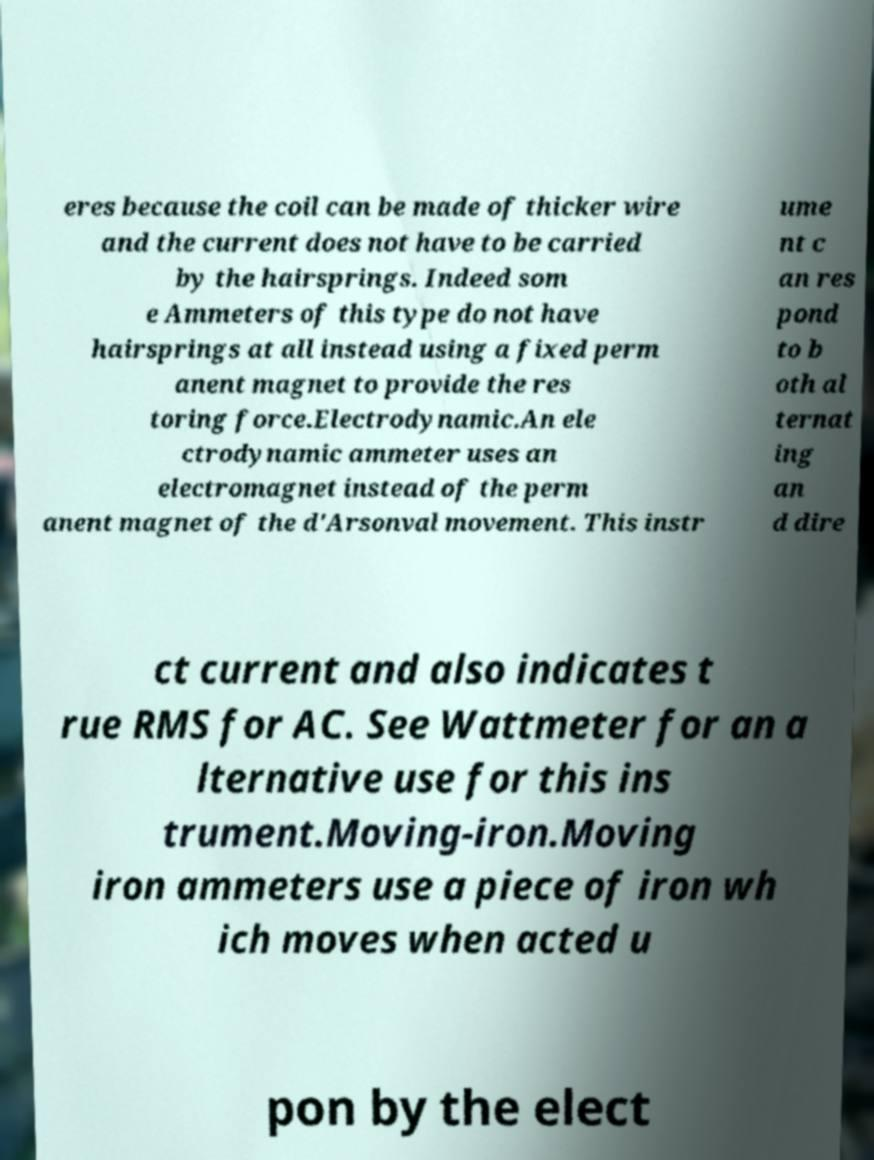Could you assist in decoding the text presented in this image and type it out clearly? eres because the coil can be made of thicker wire and the current does not have to be carried by the hairsprings. Indeed som e Ammeters of this type do not have hairsprings at all instead using a fixed perm anent magnet to provide the res toring force.Electrodynamic.An ele ctrodynamic ammeter uses an electromagnet instead of the perm anent magnet of the d'Arsonval movement. This instr ume nt c an res pond to b oth al ternat ing an d dire ct current and also indicates t rue RMS for AC. See Wattmeter for an a lternative use for this ins trument.Moving-iron.Moving iron ammeters use a piece of iron wh ich moves when acted u pon by the elect 